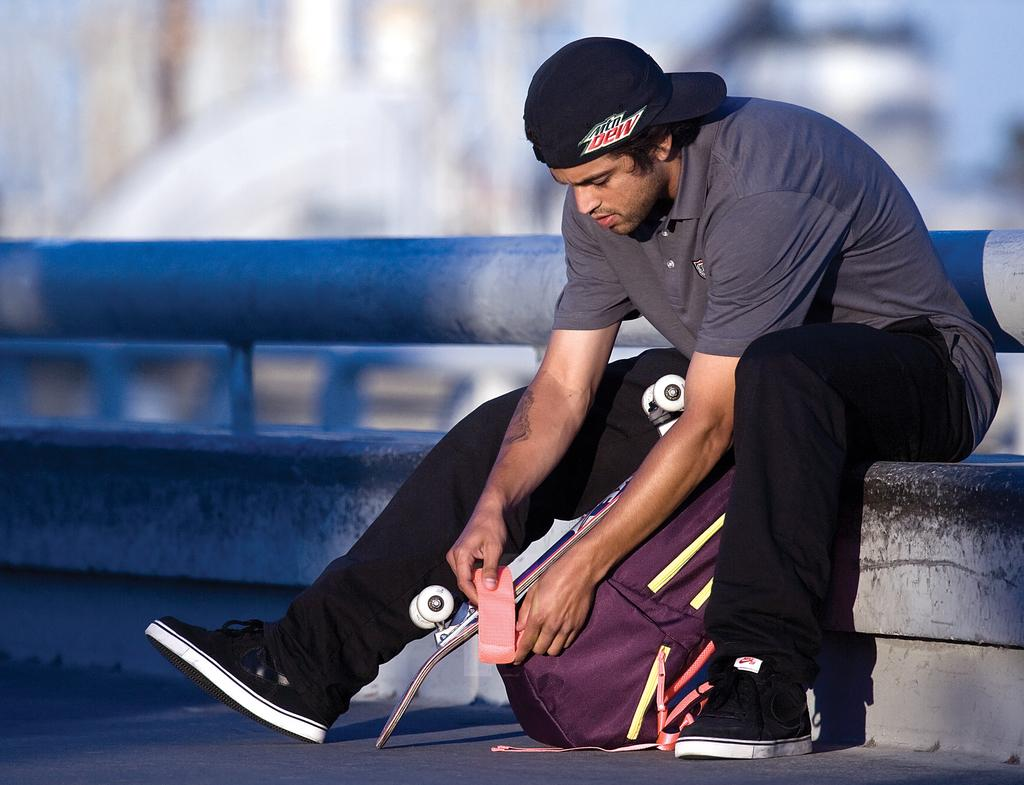What is the person in the image wearing? The person is wearing a dress and a cap. What is the person's position in the image? The person is sitting on the floor. What objects can be seen in the background of the image? There is a metal pole, a skateboard, and a bag placed on the ground in the background of the image. What type of comb is the person using in the image? There is no comb present in the image. How many days are represented by the week in the image? There is no reference to a week in the image. 